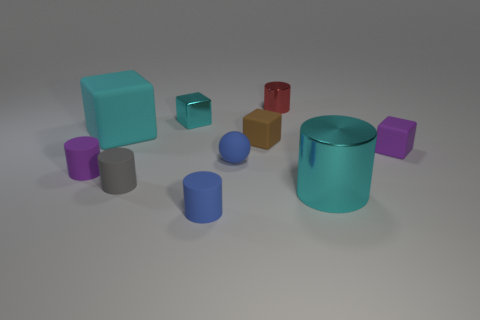Does the image seem to represent anything specific, or is it more abstract? The image appears more abstract than representational. It doesn't seem to depict a real-life scene or objects; instead, it presents an assortment of geometric shapes with aesthetic emphasis on form, color, and spatial arrangement, open to interpretation. What kind of feelings or ideas might the arrangement of these objects evoke? The arrangement of the objects might elicit a sense of order and minimalism, reflecting a modernist sentiment. It could also inspire thoughts related to the basic building blocks of visual design and evoke curiosity about the mathematical relationships between the shapes. 